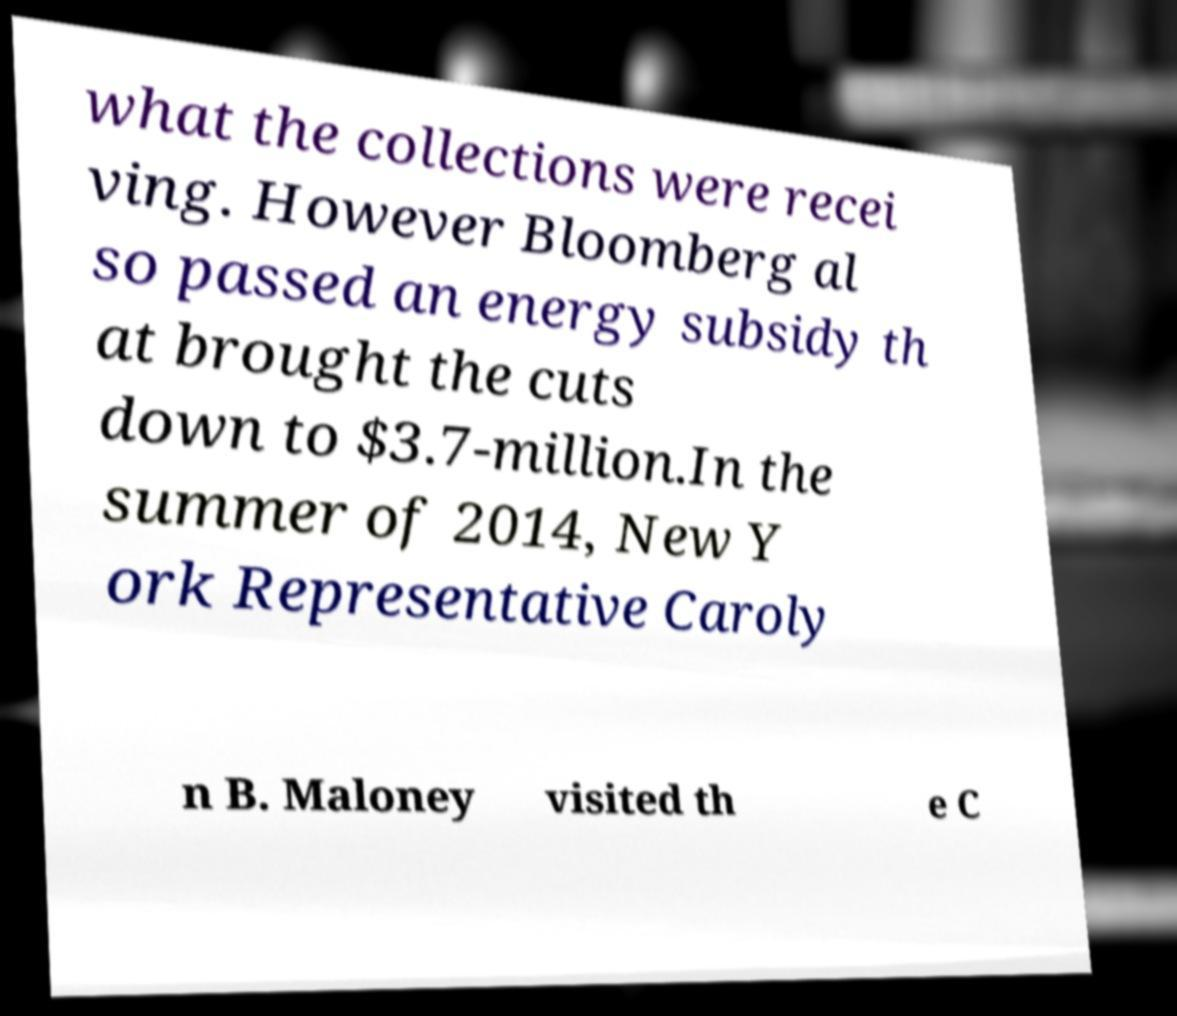Please read and relay the text visible in this image. What does it say? what the collections were recei ving. However Bloomberg al so passed an energy subsidy th at brought the cuts down to $3.7-million.In the summer of 2014, New Y ork Representative Caroly n B. Maloney visited th e C 